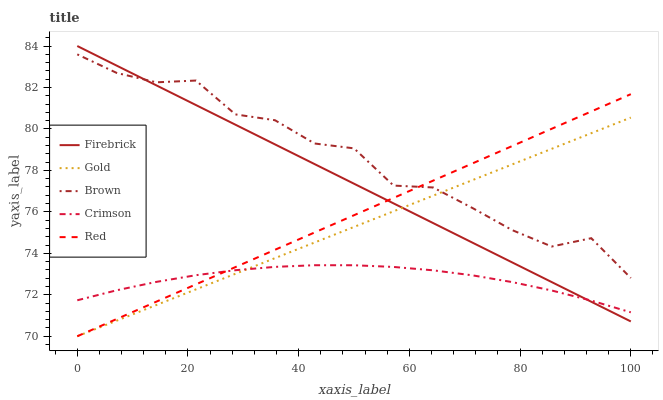Does Crimson have the minimum area under the curve?
Answer yes or no. Yes. Does Brown have the maximum area under the curve?
Answer yes or no. Yes. Does Firebrick have the minimum area under the curve?
Answer yes or no. No. Does Firebrick have the maximum area under the curve?
Answer yes or no. No. Is Gold the smoothest?
Answer yes or no. Yes. Is Brown the roughest?
Answer yes or no. Yes. Is Firebrick the smoothest?
Answer yes or no. No. Is Firebrick the roughest?
Answer yes or no. No. Does Firebrick have the lowest value?
Answer yes or no. No. Does Firebrick have the highest value?
Answer yes or no. Yes. Does Brown have the highest value?
Answer yes or no. No. Is Crimson less than Brown?
Answer yes or no. Yes. Is Brown greater than Crimson?
Answer yes or no. Yes. Does Brown intersect Firebrick?
Answer yes or no. Yes. Is Brown less than Firebrick?
Answer yes or no. No. Is Brown greater than Firebrick?
Answer yes or no. No. Does Crimson intersect Brown?
Answer yes or no. No. 